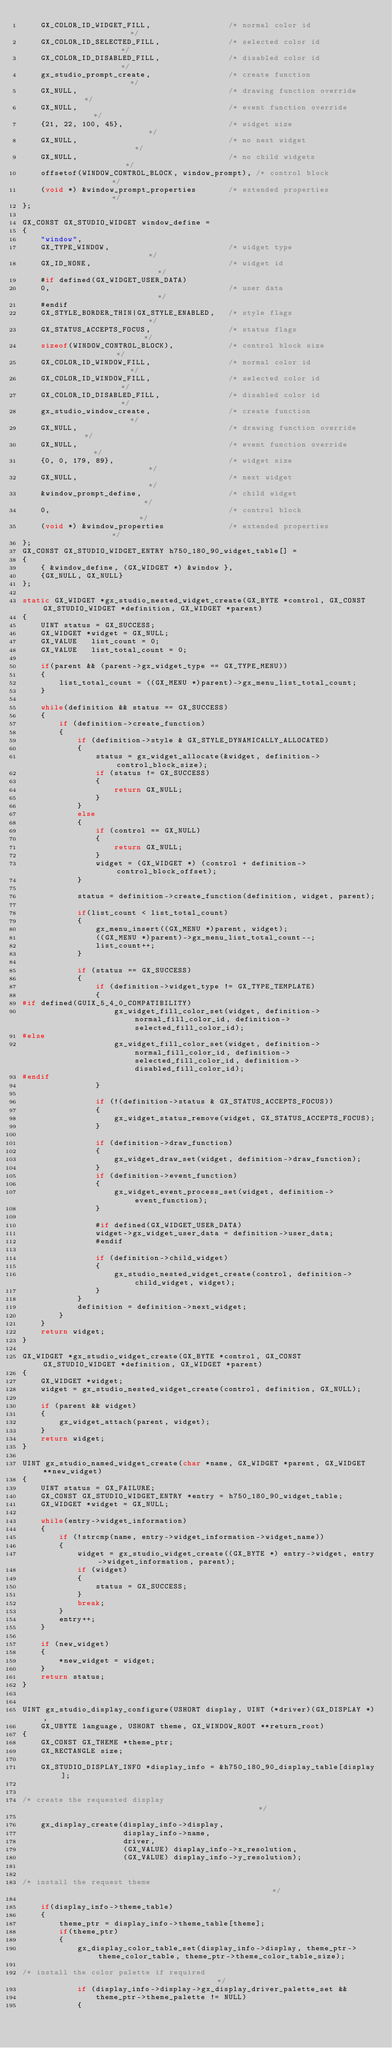<code> <loc_0><loc_0><loc_500><loc_500><_C_>    GX_COLOR_ID_WIDGET_FILL,                 /* normal color id                */
    GX_COLOR_ID_SELECTED_FILL,               /* selected color id              */
    GX_COLOR_ID_DISABLED_FILL,               /* disabled color id              */
    gx_studio_prompt_create,                 /* create function                */
    GX_NULL,                                 /* drawing function override      */
    GX_NULL,                                 /* event function override        */
    {21, 22, 100, 45},                       /* widget size                    */
    GX_NULL,                                 /* no next widget                 */
    GX_NULL,                                 /* no child widgets               */ 
    offsetof(WINDOW_CONTROL_BLOCK, window_prompt), /* control block            */
    (void *) &window_prompt_properties       /* extended properties            */
};

GX_CONST GX_STUDIO_WIDGET window_define =
{
    "window",
    GX_TYPE_WINDOW,                          /* widget type                    */
    GX_ID_NONE,                              /* widget id                      */
    #if defined(GX_WIDGET_USER_DATA)
    0,                                       /* user data                      */
    #endif
    GX_STYLE_BORDER_THIN|GX_STYLE_ENABLED,   /* style flags                    */
    GX_STATUS_ACCEPTS_FOCUS,                 /* status flags                   */
    sizeof(WINDOW_CONTROL_BLOCK),            /* control block size             */
    GX_COLOR_ID_WINDOW_FILL,                 /* normal color id                */
    GX_COLOR_ID_WINDOW_FILL,                 /* selected color id              */
    GX_COLOR_ID_DISABLED_FILL,               /* disabled color id              */
    gx_studio_window_create,                 /* create function                */
    GX_NULL,                                 /* drawing function override      */
    GX_NULL,                                 /* event function override        */
    {0, 0, 179, 89},                         /* widget size                    */
    GX_NULL,                                 /* next widget                    */
    &window_prompt_define,                   /* child widget                   */
    0,                                       /* control block                  */
    (void *) &window_properties              /* extended properties            */
};
GX_CONST GX_STUDIO_WIDGET_ENTRY h750_180_90_widget_table[] =
{
    { &window_define, (GX_WIDGET *) &window },
    {GX_NULL, GX_NULL}
};

static GX_WIDGET *gx_studio_nested_widget_create(GX_BYTE *control, GX_CONST GX_STUDIO_WIDGET *definition, GX_WIDGET *parent)
{
    UINT status = GX_SUCCESS;
    GX_WIDGET *widget = GX_NULL;
    GX_VALUE   list_count = 0;
    GX_VALUE   list_total_count = 0;

    if(parent && (parent->gx_widget_type == GX_TYPE_MENU))
    {
        list_total_count = ((GX_MENU *)parent)->gx_menu_list_total_count;
    }

    while(definition && status == GX_SUCCESS)
    {
        if (definition->create_function)
        {
            if (definition->style & GX_STYLE_DYNAMICALLY_ALLOCATED)
            {
                status = gx_widget_allocate(&widget, definition->control_block_size);
                if (status != GX_SUCCESS)
                {
                    return GX_NULL;
                }
            }
            else
            {
                if (control == GX_NULL)
                {
                    return GX_NULL;
                }
                widget = (GX_WIDGET *) (control + definition->control_block_offset);
            }

            status = definition->create_function(definition, widget, parent);

            if(list_count < list_total_count)
            {
                gx_menu_insert((GX_MENU *)parent, widget);
                ((GX_MENU *)parent)->gx_menu_list_total_count--;
                list_count++;
            }

            if (status == GX_SUCCESS)
            {
                if (definition->widget_type != GX_TYPE_TEMPLATE)
                {
#if defined(GUIX_5_4_0_COMPATIBILITY)
                    gx_widget_fill_color_set(widget, definition->normal_fill_color_id, definition->selected_fill_color_id);
#else
                    gx_widget_fill_color_set(widget, definition->normal_fill_color_id, definition->selected_fill_color_id, definition->disabled_fill_color_id);
#endif
                }

                if (!(definition->status & GX_STATUS_ACCEPTS_FOCUS))
                {
                    gx_widget_status_remove(widget, GX_STATUS_ACCEPTS_FOCUS);
                }

                if (definition->draw_function)
                {
                    gx_widget_draw_set(widget, definition->draw_function);
                }
                if (definition->event_function)
                {
                    gx_widget_event_process_set(widget, definition->event_function);
                }

                #if defined(GX_WIDGET_USER_DATA)
                widget->gx_widget_user_data = definition->user_data;
                #endif

                if (definition->child_widget)
                {
                    gx_studio_nested_widget_create(control, definition->child_widget, widget);
                }
            }
            definition = definition->next_widget;
        }
    }
    return widget;
}

GX_WIDGET *gx_studio_widget_create(GX_BYTE *control, GX_CONST GX_STUDIO_WIDGET *definition, GX_WIDGET *parent)
{
    GX_WIDGET *widget;
    widget = gx_studio_nested_widget_create(control, definition, GX_NULL);

    if (parent && widget)
    {
        gx_widget_attach(parent, widget);
    }
    return widget;
}

UINT gx_studio_named_widget_create(char *name, GX_WIDGET *parent, GX_WIDGET **new_widget)
{
    UINT status = GX_FAILURE;
    GX_CONST GX_STUDIO_WIDGET_ENTRY *entry = h750_180_90_widget_table;
    GX_WIDGET *widget = GX_NULL;

    while(entry->widget_information)
    {
        if (!strcmp(name, entry->widget_information->widget_name))
        {
            widget = gx_studio_widget_create((GX_BYTE *) entry->widget, entry->widget_information, parent);
            if (widget)
            {
                status = GX_SUCCESS;
            }
            break;
        }
        entry++;
    }

    if (new_widget)
    {
        *new_widget = widget;
    }
    return status;
}


UINT gx_studio_display_configure(USHORT display, UINT (*driver)(GX_DISPLAY *),
    GX_UBYTE language, USHORT theme, GX_WINDOW_ROOT **return_root)
{
    GX_CONST GX_THEME *theme_ptr;
    GX_RECTANGLE size;

    GX_STUDIO_DISPLAY_INFO *display_info = &h750_180_90_display_table[display];


/* create the requested display                                                */

    gx_display_create(display_info->display,
                      display_info->name,
                      driver,
                      (GX_VALUE) display_info->x_resolution,
                      (GX_VALUE) display_info->y_resolution);


/* install the request theme                                                   */

    if(display_info->theme_table)
    {
        theme_ptr = display_info->theme_table[theme];
        if(theme_ptr)
        {
            gx_display_color_table_set(display_info->display, theme_ptr->theme_color_table, theme_ptr->theme_color_table_size);
            
/* install the color palette if required                                       */
            if (display_info->display->gx_display_driver_palette_set &&
                theme_ptr->theme_palette != NULL)
            {</code> 